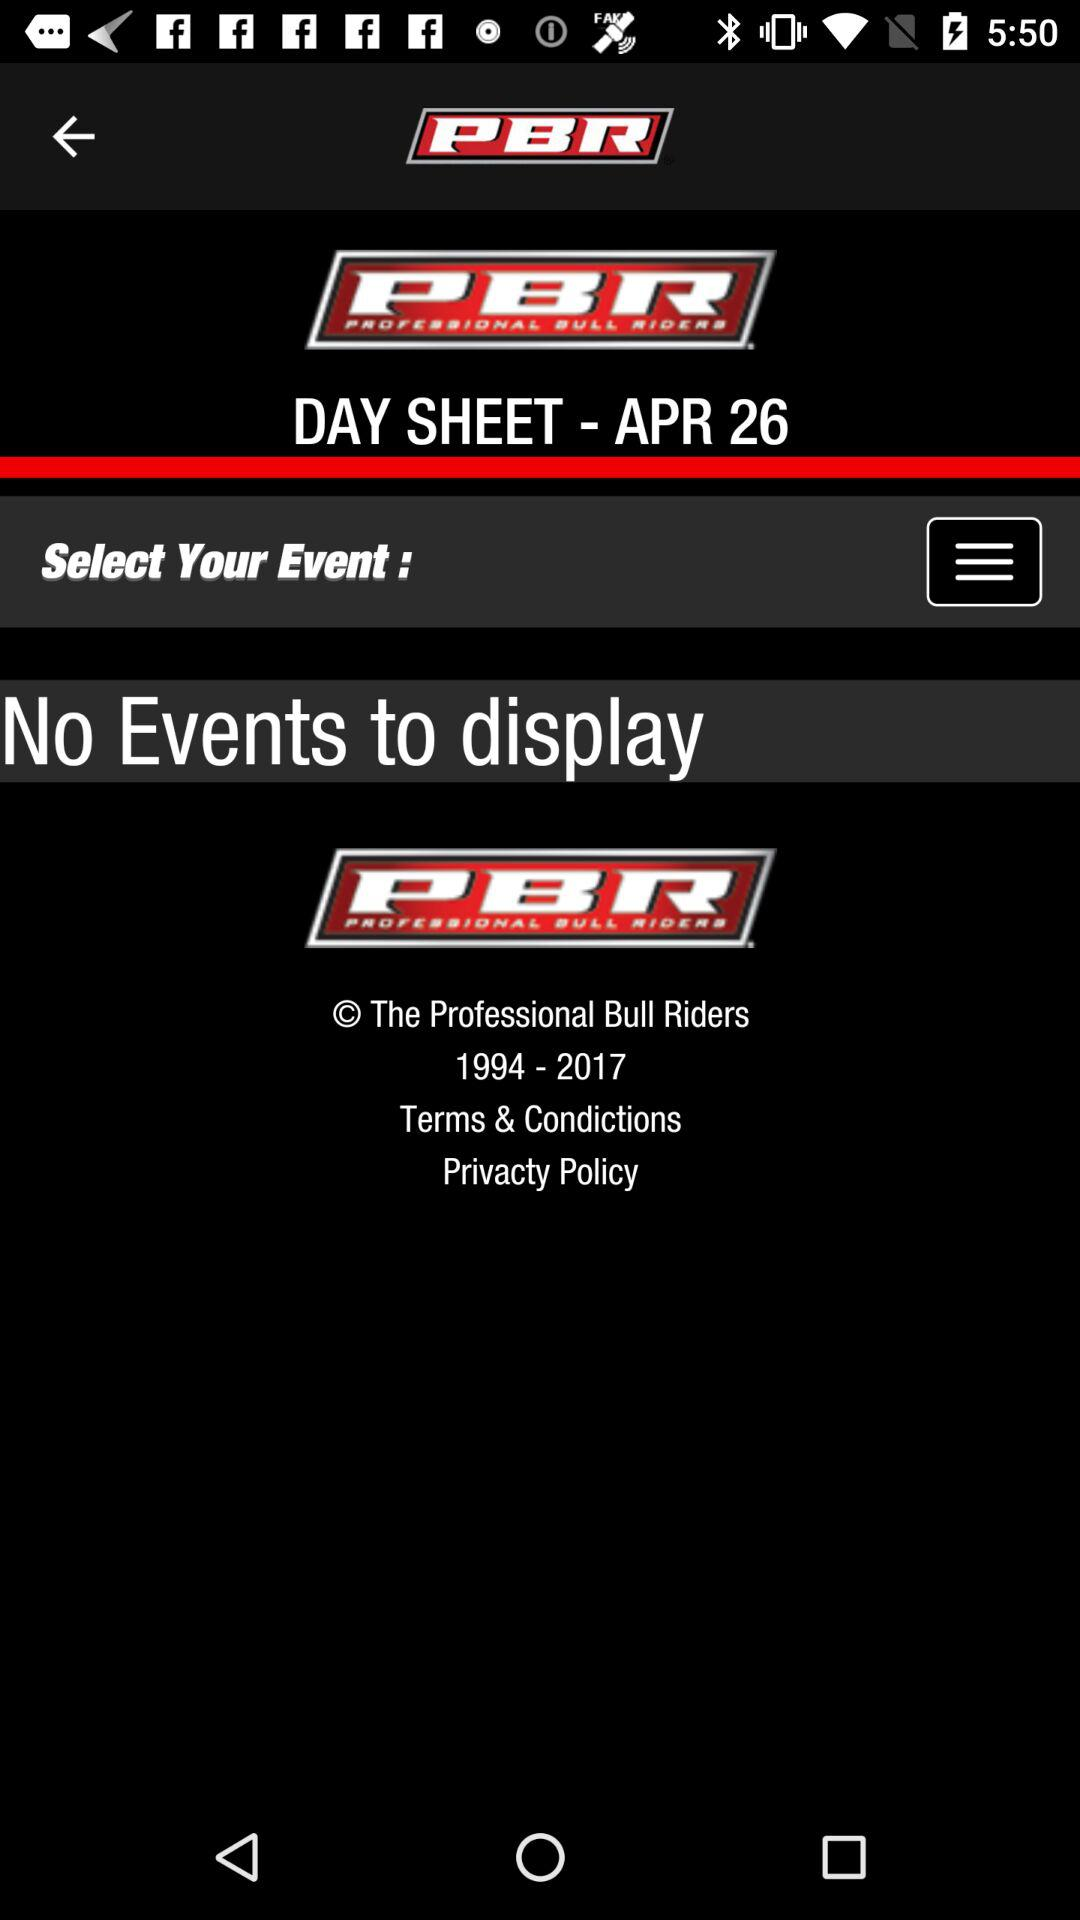How many events are there? There is no event. 